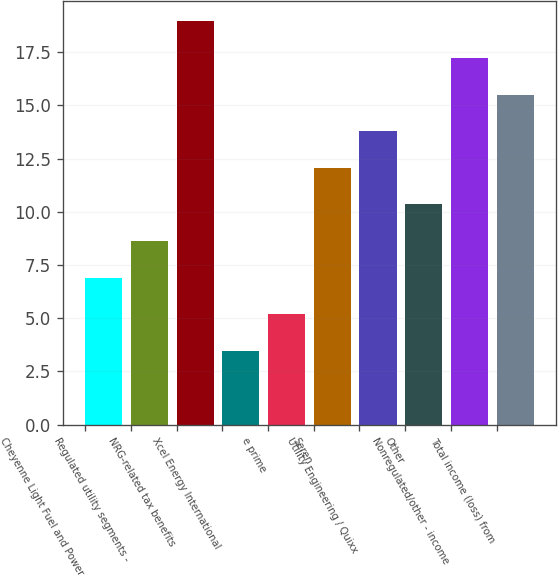Convert chart to OTSL. <chart><loc_0><loc_0><loc_500><loc_500><bar_chart><fcel>Cheyenne Light Fuel and Power<fcel>Regulated utility segments -<fcel>NRG-related tax benefits<fcel>Xcel Energy International<fcel>e prime<fcel>Seren<fcel>Utility Engineering / Quixx<fcel>Other<fcel>Nonregulated/other - income<fcel>Total income (loss) from<nl><fcel>6.91<fcel>8.63<fcel>18.95<fcel>3.47<fcel>5.19<fcel>12.07<fcel>13.79<fcel>10.35<fcel>17.23<fcel>15.51<nl></chart> 